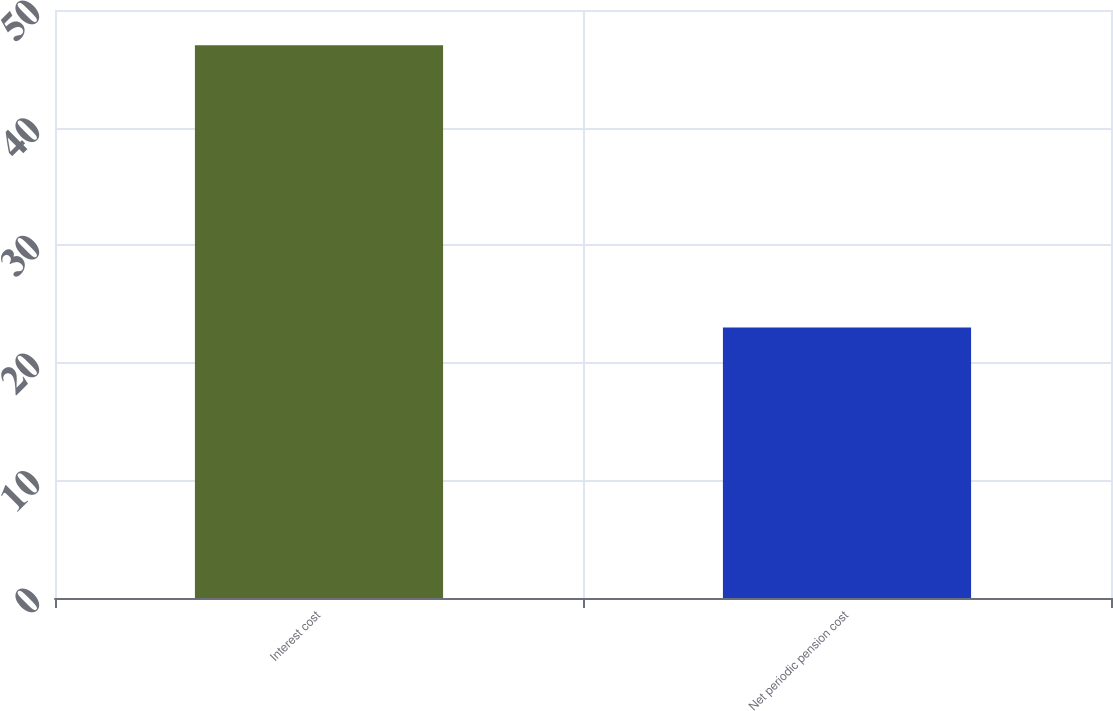Convert chart to OTSL. <chart><loc_0><loc_0><loc_500><loc_500><bar_chart><fcel>Interest cost<fcel>Net periodic pension cost<nl><fcel>47<fcel>23<nl></chart> 